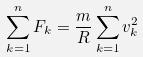<formula> <loc_0><loc_0><loc_500><loc_500>\sum _ { k = 1 } ^ { n } F _ { k } = \frac { m } { R } \sum _ { k = 1 } ^ { n } v _ { k } ^ { 2 }</formula> 